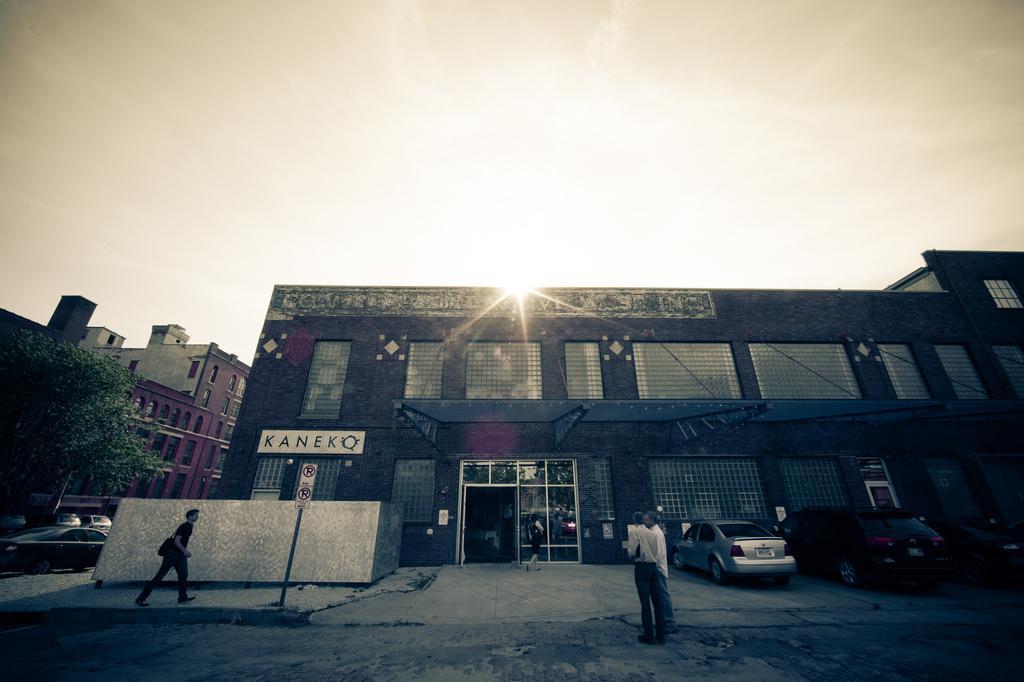In one or two sentences, can you explain what this image depicts? In this picture we can see buildings, there are two persons standing in the front, on the right side and left side we can see cars, there is a tree on the left side, we can see a person is walking on the left side, there is the sky at the top of the picture, we can see a board in the middle. 